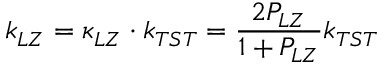Convert formula to latex. <formula><loc_0><loc_0><loc_500><loc_500>k _ { L Z } = \kappa _ { L Z } \cdot k _ { T S T } = \frac { 2 P _ { L Z } } { 1 + P _ { L Z } } k _ { T S T }</formula> 